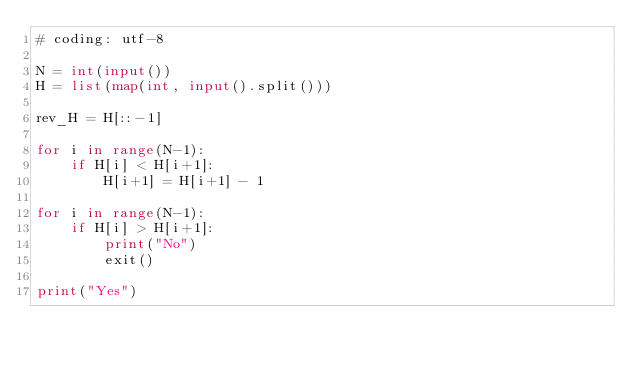Convert code to text. <code><loc_0><loc_0><loc_500><loc_500><_Python_># coding: utf-8

N = int(input())
H = list(map(int, input().split()))

rev_H = H[::-1]

for i in range(N-1):
    if H[i] < H[i+1]:
        H[i+1] = H[i+1] - 1

for i in range(N-1):
    if H[i] > H[i+1]:
        print("No")
        exit()

print("Yes")</code> 